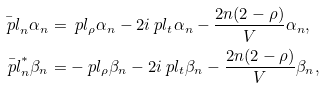<formula> <loc_0><loc_0><loc_500><loc_500>\bar { \ p l } _ { n } \alpha _ { n } & = \ p l _ { \rho } \alpha _ { n } - 2 i \ p l _ { t } \alpha _ { n } - \frac { 2 n ( 2 - \rho ) } { V } \alpha _ { n } , \\ \bar { \ p l } ^ { * } _ { n } \beta _ { n } & = - \ p l _ { \rho } \beta _ { n } - 2 i \ p l _ { t } \beta _ { n } - \frac { 2 n ( 2 - \rho ) } { V } \beta _ { n } ,</formula> 